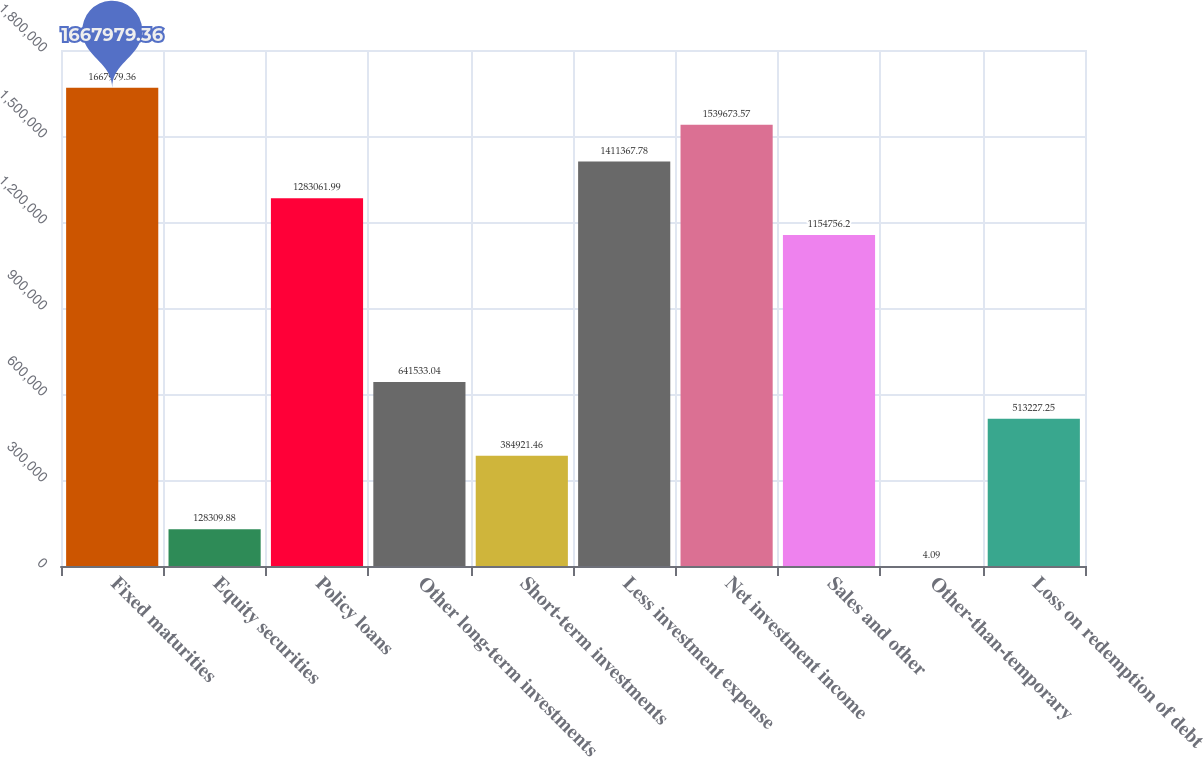<chart> <loc_0><loc_0><loc_500><loc_500><bar_chart><fcel>Fixed maturities<fcel>Equity securities<fcel>Policy loans<fcel>Other long-term investments<fcel>Short-term investments<fcel>Less investment expense<fcel>Net investment income<fcel>Sales and other<fcel>Other-than-temporary<fcel>Loss on redemption of debt<nl><fcel>1.66798e+06<fcel>128310<fcel>1.28306e+06<fcel>641533<fcel>384921<fcel>1.41137e+06<fcel>1.53967e+06<fcel>1.15476e+06<fcel>4.09<fcel>513227<nl></chart> 